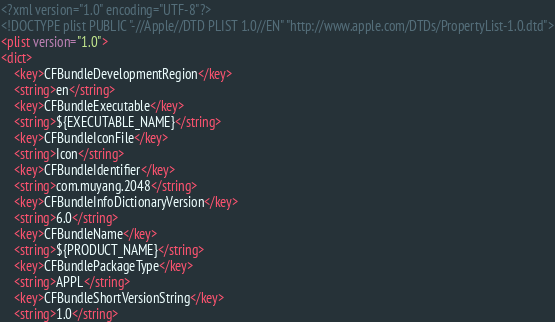Convert code to text. <code><loc_0><loc_0><loc_500><loc_500><_XML_><?xml version="1.0" encoding="UTF-8"?>
<!DOCTYPE plist PUBLIC "-//Apple//DTD PLIST 1.0//EN" "http://www.apple.com/DTDs/PropertyList-1.0.dtd">
<plist version="1.0">
<dict>
	<key>CFBundleDevelopmentRegion</key>
	<string>en</string>
	<key>CFBundleExecutable</key>
	<string>${EXECUTABLE_NAME}</string>
	<key>CFBundleIconFile</key>
	<string>Icon</string>
	<key>CFBundleIdentifier</key>
	<string>com.muyang.2048</string>
	<key>CFBundleInfoDictionaryVersion</key>
	<string>6.0</string>
	<key>CFBundleName</key>
	<string>${PRODUCT_NAME}</string>
	<key>CFBundlePackageType</key>
	<string>APPL</string>
	<key>CFBundleShortVersionString</key>
	<string>1.0</string></code> 